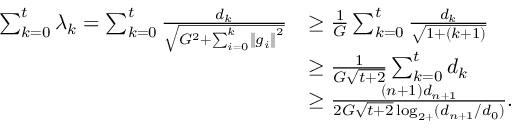<formula> <loc_0><loc_0><loc_500><loc_500>\begin{array} { r l } { \sum _ { k = 0 } ^ { t } \lambda _ { k } = \sum _ { k = 0 } ^ { t } \frac { d _ { k } } { \sqrt { G ^ { 2 } + \sum _ { i = 0 } ^ { k } \left \| g _ { i } \right \| ^ { 2 } } } } & { \geq \frac { 1 } { G } \sum _ { k = 0 } ^ { t } \frac { d _ { k } } { \sqrt { 1 + ( k + 1 ) } } } \\ & { \geq \frac { 1 } { G \sqrt { t + 2 } } \sum _ { k = 0 } ^ { t } d _ { k } } \\ & { \geq \frac { \left ( n + 1 \right ) d _ { n + 1 } } { 2 G \sqrt { t + 2 } \log _ { 2 + } ( d _ { n + 1 } / d _ { 0 } ) } . } \end{array}</formula> 